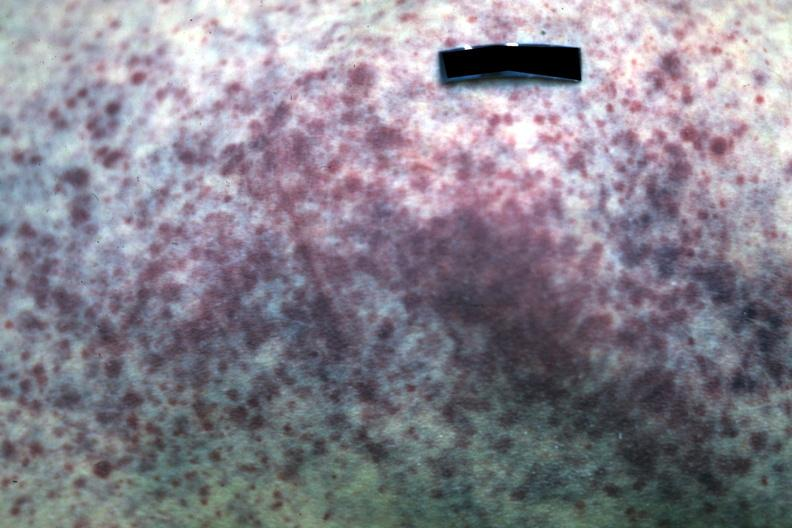what is present?
Answer the question using a single word or phrase. Petechiae 